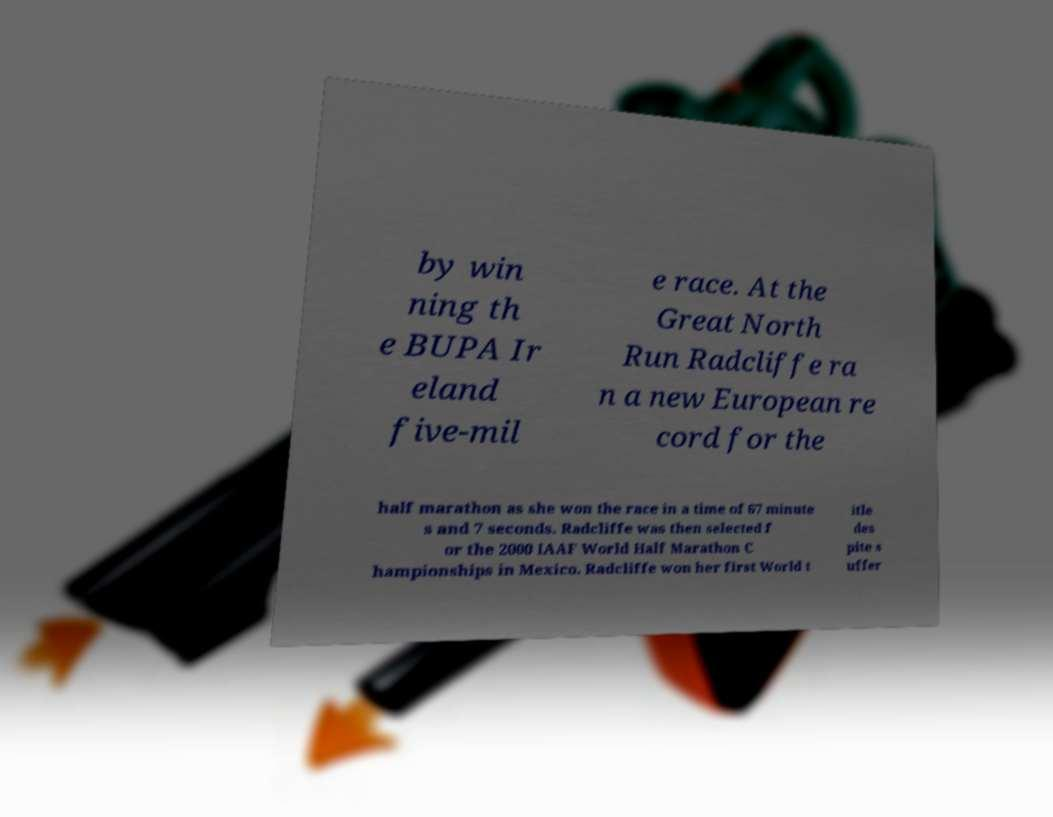Could you extract and type out the text from this image? by win ning th e BUPA Ir eland five-mil e race. At the Great North Run Radcliffe ra n a new European re cord for the half marathon as she won the race in a time of 67 minute s and 7 seconds. Radcliffe was then selected f or the 2000 IAAF World Half Marathon C hampionships in Mexico. Radcliffe won her first World t itle des pite s uffer 